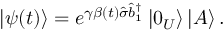<formula> <loc_0><loc_0><loc_500><loc_500>\left | \psi ( t ) \right \rangle = e ^ { \gamma \beta ( t ) \hat { \sigma } \hat { b } _ { 1 } ^ { \dagger } } \left | 0 _ { U } \right \rangle \left | A \right \rangle .</formula> 